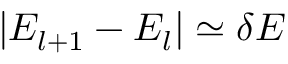<formula> <loc_0><loc_0><loc_500><loc_500>| E _ { l + 1 } - E _ { l } | \simeq \delta E</formula> 